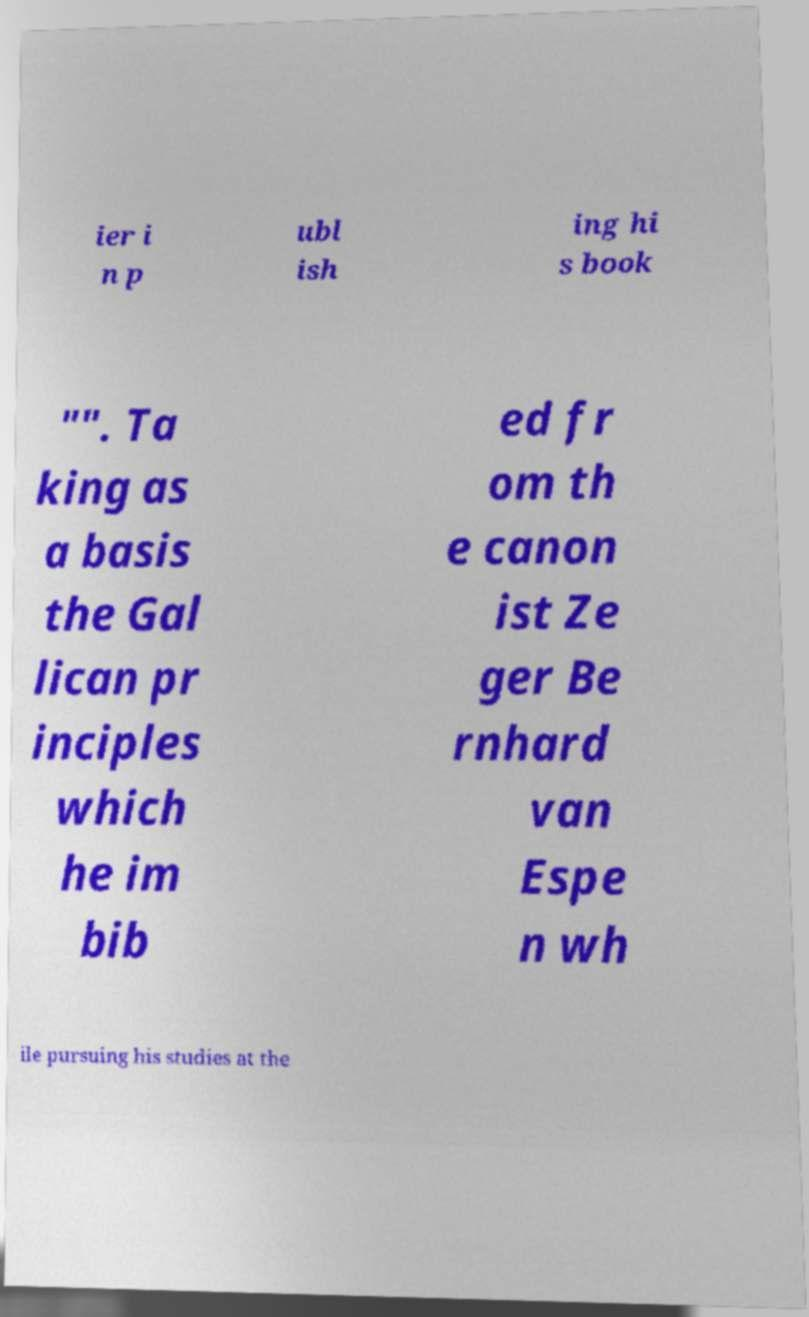Can you read and provide the text displayed in the image?This photo seems to have some interesting text. Can you extract and type it out for me? ier i n p ubl ish ing hi s book "". Ta king as a basis the Gal lican pr inciples which he im bib ed fr om th e canon ist Ze ger Be rnhard van Espe n wh ile pursuing his studies at the 